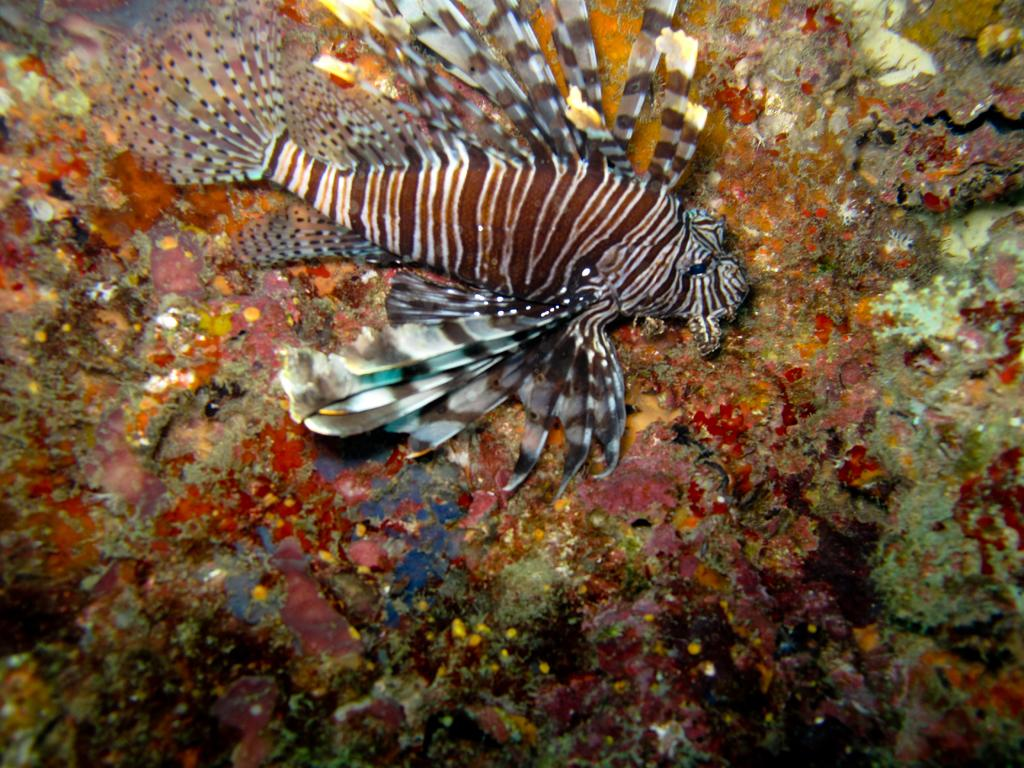What type of animal is present in the image? There is a fish in the image. Can you describe the setting of the image? The image depicts an underwater environment. What type of attraction can be seen in the image? There is no attraction present in the image; it depicts an underwater environment with a fish. What role does coal play in the image? There is no coal present in the image; it is an underwater scene with a fish. 